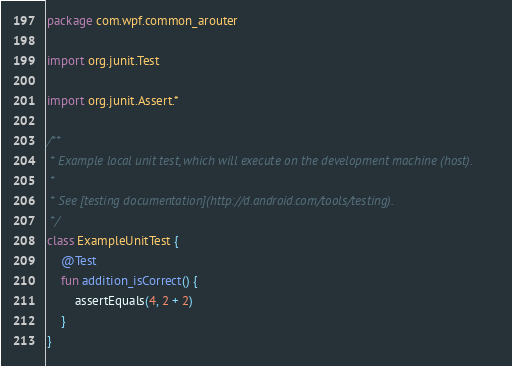<code> <loc_0><loc_0><loc_500><loc_500><_Kotlin_>package com.wpf.common_arouter

import org.junit.Test

import org.junit.Assert.*

/**
 * Example local unit test, which will execute on the development machine (host).
 *
 * See [testing documentation](http://d.android.com/tools/testing).
 */
class ExampleUnitTest {
    @Test
    fun addition_isCorrect() {
        assertEquals(4, 2 + 2)
    }
}</code> 